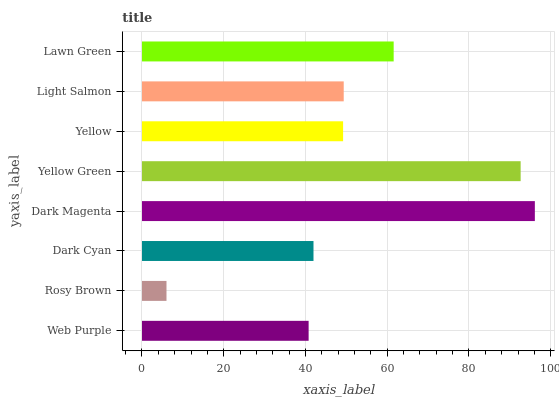Is Rosy Brown the minimum?
Answer yes or no. Yes. Is Dark Magenta the maximum?
Answer yes or no. Yes. Is Dark Cyan the minimum?
Answer yes or no. No. Is Dark Cyan the maximum?
Answer yes or no. No. Is Dark Cyan greater than Rosy Brown?
Answer yes or no. Yes. Is Rosy Brown less than Dark Cyan?
Answer yes or no. Yes. Is Rosy Brown greater than Dark Cyan?
Answer yes or no. No. Is Dark Cyan less than Rosy Brown?
Answer yes or no. No. Is Light Salmon the high median?
Answer yes or no. Yes. Is Yellow the low median?
Answer yes or no. Yes. Is Dark Cyan the high median?
Answer yes or no. No. Is Rosy Brown the low median?
Answer yes or no. No. 